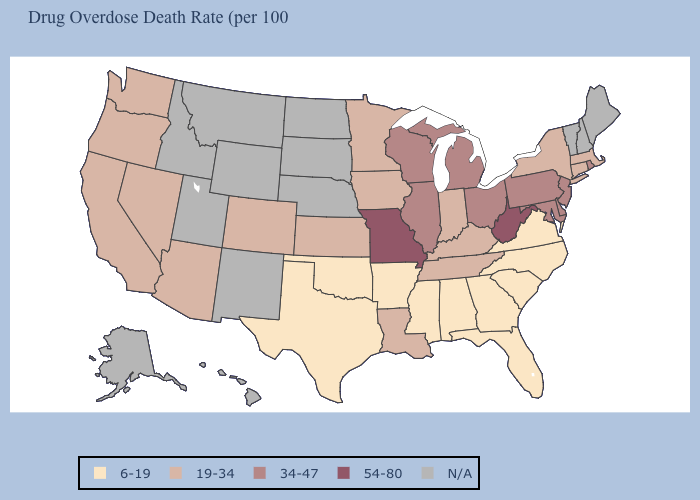Does the map have missing data?
Quick response, please. Yes. Is the legend a continuous bar?
Answer briefly. No. Does the map have missing data?
Write a very short answer. Yes. Does North Carolina have the lowest value in the USA?
Concise answer only. Yes. Does the map have missing data?
Concise answer only. Yes. What is the highest value in the USA?
Give a very brief answer. 54-80. Does Arkansas have the lowest value in the USA?
Write a very short answer. Yes. Name the states that have a value in the range 34-47?
Write a very short answer. Delaware, Illinois, Maryland, Michigan, New Jersey, Ohio, Pennsylvania, Rhode Island, Wisconsin. What is the value of Hawaii?
Be succinct. N/A. How many symbols are there in the legend?
Give a very brief answer. 5. Among the states that border New Jersey , which have the lowest value?
Short answer required. New York. How many symbols are there in the legend?
Answer briefly. 5. 